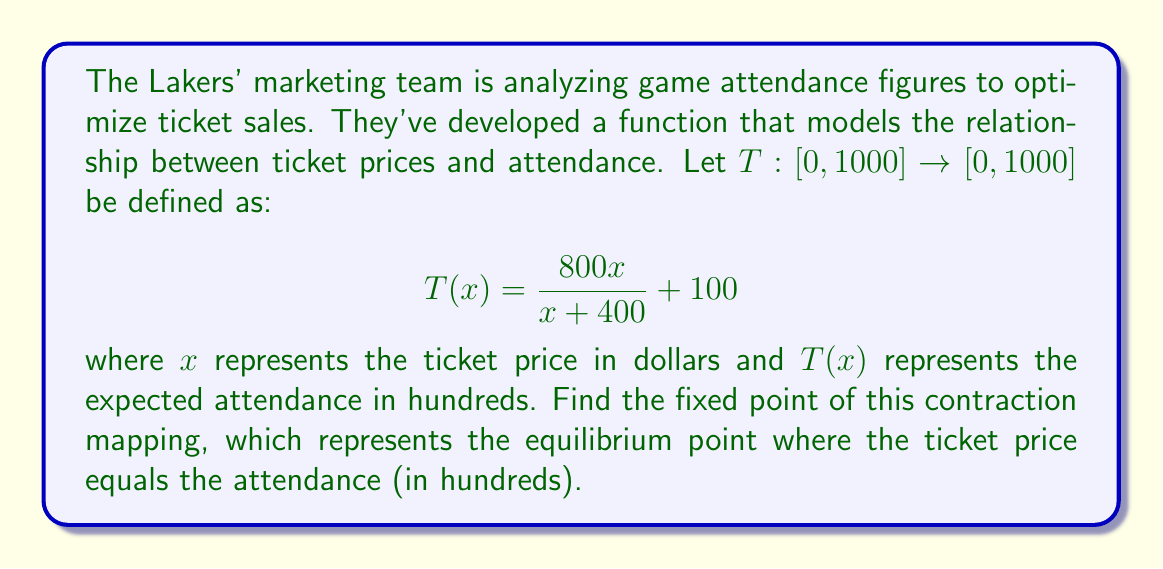Could you help me with this problem? To find the fixed point of the contraction mapping, we need to solve the equation $T(x) = x$. This means:

$$\frac{800x}{x + 400} + 100 = x$$

Let's solve this step by step:

1) First, multiply both sides by $(x + 400)$:
   $800x + 100(x + 400) = x(x + 400)$

2) Expand the right side:
   $800x + 100x + 40000 = x^2 + 400x$

3) Rearrange terms:
   $x^2 - 500x - 40000 = 0$

4) This is a quadratic equation. We can solve it using the quadratic formula:
   $x = \frac{-b \pm \sqrt{b^2 - 4ac}}{2a}$

   Where $a = 1$, $b = -500$, and $c = -40000$

5) Plugging in these values:
   $x = \frac{500 \pm \sqrt{250000 + 160000}}{2} = \frac{500 \pm \sqrt{410000}}{2}$

6) Simplify:
   $x = \frac{500 \pm 640}{2}$

7) This gives us two solutions:
   $x_1 = \frac{500 + 640}{2} = 570$
   $x_2 = \frac{500 - 640}{2} = -70$

8) Since we're dealing with ticket prices, we can discard the negative solution.

Therefore, the fixed point of the contraction mapping is 570.
Answer: The fixed point of the contraction mapping is $570$. 